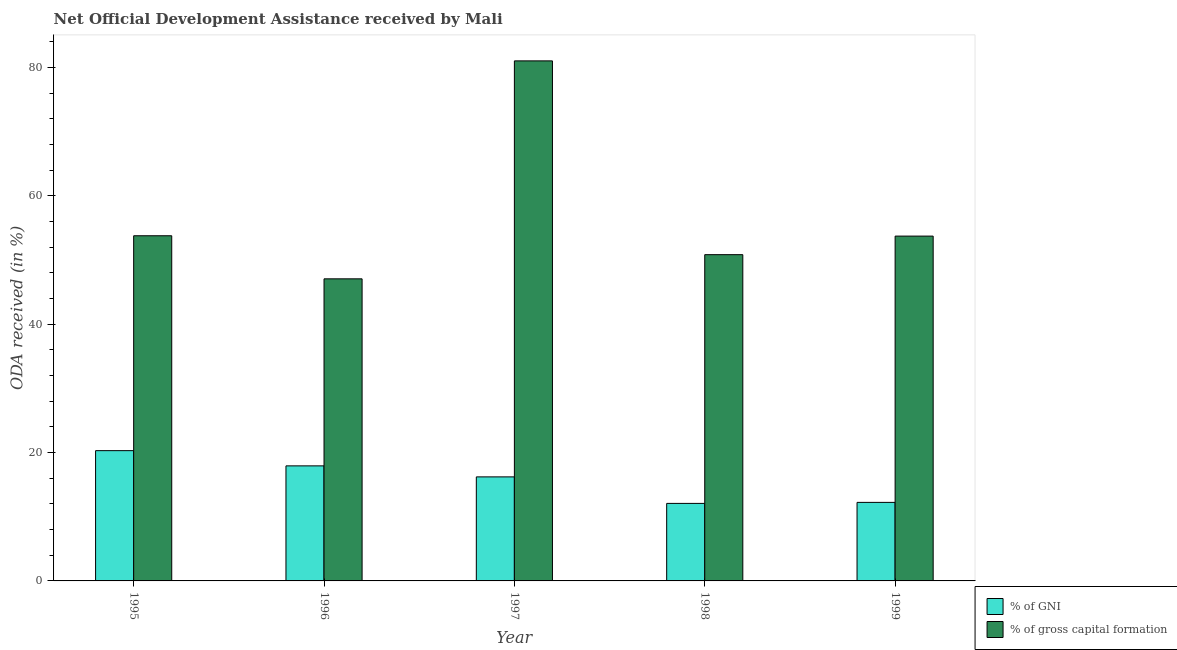How many groups of bars are there?
Provide a short and direct response. 5. Are the number of bars on each tick of the X-axis equal?
Offer a very short reply. Yes. How many bars are there on the 1st tick from the left?
Make the answer very short. 2. What is the oda received as percentage of gni in 1997?
Give a very brief answer. 16.22. Across all years, what is the maximum oda received as percentage of gross capital formation?
Provide a short and direct response. 81.05. Across all years, what is the minimum oda received as percentage of gross capital formation?
Your answer should be compact. 47.08. In which year was the oda received as percentage of gni maximum?
Offer a terse response. 1995. In which year was the oda received as percentage of gross capital formation minimum?
Make the answer very short. 1996. What is the total oda received as percentage of gni in the graph?
Keep it short and to the point. 78.78. What is the difference between the oda received as percentage of gross capital formation in 1996 and that in 1998?
Offer a terse response. -3.77. What is the difference between the oda received as percentage of gni in 1995 and the oda received as percentage of gross capital formation in 1998?
Your response must be concise. 8.22. What is the average oda received as percentage of gni per year?
Offer a very short reply. 15.76. In the year 1999, what is the difference between the oda received as percentage of gross capital formation and oda received as percentage of gni?
Keep it short and to the point. 0. In how many years, is the oda received as percentage of gross capital formation greater than 8 %?
Your answer should be compact. 5. What is the ratio of the oda received as percentage of gni in 1995 to that in 1999?
Provide a short and direct response. 1.66. Is the oda received as percentage of gross capital formation in 1998 less than that in 1999?
Provide a short and direct response. Yes. What is the difference between the highest and the second highest oda received as percentage of gni?
Your response must be concise. 2.37. What is the difference between the highest and the lowest oda received as percentage of gni?
Your response must be concise. 8.22. Is the sum of the oda received as percentage of gni in 1995 and 1998 greater than the maximum oda received as percentage of gross capital formation across all years?
Give a very brief answer. Yes. What does the 1st bar from the left in 1997 represents?
Your answer should be very brief. % of GNI. What does the 1st bar from the right in 1995 represents?
Offer a very short reply. % of gross capital formation. How many bars are there?
Provide a succinct answer. 10. Are all the bars in the graph horizontal?
Provide a short and direct response. No. What is the difference between two consecutive major ticks on the Y-axis?
Give a very brief answer. 20. Does the graph contain grids?
Make the answer very short. No. Where does the legend appear in the graph?
Make the answer very short. Bottom right. How are the legend labels stacked?
Ensure brevity in your answer.  Vertical. What is the title of the graph?
Provide a short and direct response. Net Official Development Assistance received by Mali. Does "Central government" appear as one of the legend labels in the graph?
Provide a short and direct response. No. What is the label or title of the Y-axis?
Your response must be concise. ODA received (in %). What is the ODA received (in %) in % of GNI in 1995?
Provide a short and direct response. 20.3. What is the ODA received (in %) of % of gross capital formation in 1995?
Provide a succinct answer. 53.8. What is the ODA received (in %) of % of GNI in 1996?
Offer a very short reply. 17.93. What is the ODA received (in %) of % of gross capital formation in 1996?
Provide a succinct answer. 47.08. What is the ODA received (in %) in % of GNI in 1997?
Offer a very short reply. 16.22. What is the ODA received (in %) in % of gross capital formation in 1997?
Offer a very short reply. 81.05. What is the ODA received (in %) in % of GNI in 1998?
Provide a succinct answer. 12.08. What is the ODA received (in %) in % of gross capital formation in 1998?
Provide a succinct answer. 50.85. What is the ODA received (in %) in % of GNI in 1999?
Your answer should be very brief. 12.24. What is the ODA received (in %) in % of gross capital formation in 1999?
Offer a very short reply. 53.74. Across all years, what is the maximum ODA received (in %) of % of GNI?
Give a very brief answer. 20.3. Across all years, what is the maximum ODA received (in %) in % of gross capital formation?
Your answer should be compact. 81.05. Across all years, what is the minimum ODA received (in %) of % of GNI?
Provide a succinct answer. 12.08. Across all years, what is the minimum ODA received (in %) in % of gross capital formation?
Your answer should be compact. 47.08. What is the total ODA received (in %) in % of GNI in the graph?
Keep it short and to the point. 78.78. What is the total ODA received (in %) of % of gross capital formation in the graph?
Offer a very short reply. 286.53. What is the difference between the ODA received (in %) in % of GNI in 1995 and that in 1996?
Ensure brevity in your answer.  2.37. What is the difference between the ODA received (in %) in % of gross capital formation in 1995 and that in 1996?
Keep it short and to the point. 6.71. What is the difference between the ODA received (in %) of % of GNI in 1995 and that in 1997?
Offer a terse response. 4.09. What is the difference between the ODA received (in %) of % of gross capital formation in 1995 and that in 1997?
Make the answer very short. -27.26. What is the difference between the ODA received (in %) of % of GNI in 1995 and that in 1998?
Offer a terse response. 8.22. What is the difference between the ODA received (in %) in % of gross capital formation in 1995 and that in 1998?
Your response must be concise. 2.95. What is the difference between the ODA received (in %) of % of GNI in 1995 and that in 1999?
Provide a short and direct response. 8.06. What is the difference between the ODA received (in %) of % of gross capital formation in 1995 and that in 1999?
Ensure brevity in your answer.  0.05. What is the difference between the ODA received (in %) in % of GNI in 1996 and that in 1997?
Offer a very short reply. 1.72. What is the difference between the ODA received (in %) in % of gross capital formation in 1996 and that in 1997?
Provide a succinct answer. -33.97. What is the difference between the ODA received (in %) of % of GNI in 1996 and that in 1998?
Provide a short and direct response. 5.85. What is the difference between the ODA received (in %) of % of gross capital formation in 1996 and that in 1998?
Keep it short and to the point. -3.77. What is the difference between the ODA received (in %) of % of GNI in 1996 and that in 1999?
Make the answer very short. 5.69. What is the difference between the ODA received (in %) of % of gross capital formation in 1996 and that in 1999?
Your answer should be compact. -6.66. What is the difference between the ODA received (in %) in % of GNI in 1997 and that in 1998?
Keep it short and to the point. 4.13. What is the difference between the ODA received (in %) in % of gross capital formation in 1997 and that in 1998?
Your response must be concise. 30.2. What is the difference between the ODA received (in %) in % of GNI in 1997 and that in 1999?
Make the answer very short. 3.97. What is the difference between the ODA received (in %) in % of gross capital formation in 1997 and that in 1999?
Ensure brevity in your answer.  27.31. What is the difference between the ODA received (in %) of % of GNI in 1998 and that in 1999?
Make the answer very short. -0.16. What is the difference between the ODA received (in %) in % of gross capital formation in 1998 and that in 1999?
Offer a terse response. -2.89. What is the difference between the ODA received (in %) in % of GNI in 1995 and the ODA received (in %) in % of gross capital formation in 1996?
Keep it short and to the point. -26.78. What is the difference between the ODA received (in %) in % of GNI in 1995 and the ODA received (in %) in % of gross capital formation in 1997?
Your answer should be compact. -60.75. What is the difference between the ODA received (in %) in % of GNI in 1995 and the ODA received (in %) in % of gross capital formation in 1998?
Provide a succinct answer. -30.55. What is the difference between the ODA received (in %) of % of GNI in 1995 and the ODA received (in %) of % of gross capital formation in 1999?
Make the answer very short. -33.44. What is the difference between the ODA received (in %) of % of GNI in 1996 and the ODA received (in %) of % of gross capital formation in 1997?
Make the answer very short. -63.12. What is the difference between the ODA received (in %) of % of GNI in 1996 and the ODA received (in %) of % of gross capital formation in 1998?
Provide a succinct answer. -32.92. What is the difference between the ODA received (in %) of % of GNI in 1996 and the ODA received (in %) of % of gross capital formation in 1999?
Offer a very short reply. -35.81. What is the difference between the ODA received (in %) in % of GNI in 1997 and the ODA received (in %) in % of gross capital formation in 1998?
Your answer should be compact. -34.63. What is the difference between the ODA received (in %) of % of GNI in 1997 and the ODA received (in %) of % of gross capital formation in 1999?
Offer a terse response. -37.53. What is the difference between the ODA received (in %) of % of GNI in 1998 and the ODA received (in %) of % of gross capital formation in 1999?
Keep it short and to the point. -41.66. What is the average ODA received (in %) of % of GNI per year?
Your answer should be very brief. 15.76. What is the average ODA received (in %) of % of gross capital formation per year?
Offer a very short reply. 57.31. In the year 1995, what is the difference between the ODA received (in %) of % of GNI and ODA received (in %) of % of gross capital formation?
Ensure brevity in your answer.  -33.49. In the year 1996, what is the difference between the ODA received (in %) of % of GNI and ODA received (in %) of % of gross capital formation?
Ensure brevity in your answer.  -29.15. In the year 1997, what is the difference between the ODA received (in %) of % of GNI and ODA received (in %) of % of gross capital formation?
Make the answer very short. -64.84. In the year 1998, what is the difference between the ODA received (in %) in % of GNI and ODA received (in %) in % of gross capital formation?
Offer a terse response. -38.77. In the year 1999, what is the difference between the ODA received (in %) in % of GNI and ODA received (in %) in % of gross capital formation?
Provide a short and direct response. -41.5. What is the ratio of the ODA received (in %) in % of GNI in 1995 to that in 1996?
Your response must be concise. 1.13. What is the ratio of the ODA received (in %) in % of gross capital formation in 1995 to that in 1996?
Provide a short and direct response. 1.14. What is the ratio of the ODA received (in %) in % of GNI in 1995 to that in 1997?
Your answer should be very brief. 1.25. What is the ratio of the ODA received (in %) in % of gross capital formation in 1995 to that in 1997?
Keep it short and to the point. 0.66. What is the ratio of the ODA received (in %) of % of GNI in 1995 to that in 1998?
Offer a very short reply. 1.68. What is the ratio of the ODA received (in %) of % of gross capital formation in 1995 to that in 1998?
Ensure brevity in your answer.  1.06. What is the ratio of the ODA received (in %) in % of GNI in 1995 to that in 1999?
Make the answer very short. 1.66. What is the ratio of the ODA received (in %) in % of GNI in 1996 to that in 1997?
Your answer should be very brief. 1.11. What is the ratio of the ODA received (in %) of % of gross capital formation in 1996 to that in 1997?
Provide a short and direct response. 0.58. What is the ratio of the ODA received (in %) of % of GNI in 1996 to that in 1998?
Your response must be concise. 1.48. What is the ratio of the ODA received (in %) of % of gross capital formation in 1996 to that in 1998?
Ensure brevity in your answer.  0.93. What is the ratio of the ODA received (in %) of % of GNI in 1996 to that in 1999?
Give a very brief answer. 1.46. What is the ratio of the ODA received (in %) in % of gross capital formation in 1996 to that in 1999?
Provide a short and direct response. 0.88. What is the ratio of the ODA received (in %) of % of GNI in 1997 to that in 1998?
Keep it short and to the point. 1.34. What is the ratio of the ODA received (in %) of % of gross capital formation in 1997 to that in 1998?
Your answer should be compact. 1.59. What is the ratio of the ODA received (in %) of % of GNI in 1997 to that in 1999?
Keep it short and to the point. 1.32. What is the ratio of the ODA received (in %) of % of gross capital formation in 1997 to that in 1999?
Offer a terse response. 1.51. What is the ratio of the ODA received (in %) in % of GNI in 1998 to that in 1999?
Provide a short and direct response. 0.99. What is the ratio of the ODA received (in %) in % of gross capital formation in 1998 to that in 1999?
Give a very brief answer. 0.95. What is the difference between the highest and the second highest ODA received (in %) in % of GNI?
Offer a terse response. 2.37. What is the difference between the highest and the second highest ODA received (in %) of % of gross capital formation?
Your response must be concise. 27.26. What is the difference between the highest and the lowest ODA received (in %) of % of GNI?
Provide a succinct answer. 8.22. What is the difference between the highest and the lowest ODA received (in %) of % of gross capital formation?
Keep it short and to the point. 33.97. 